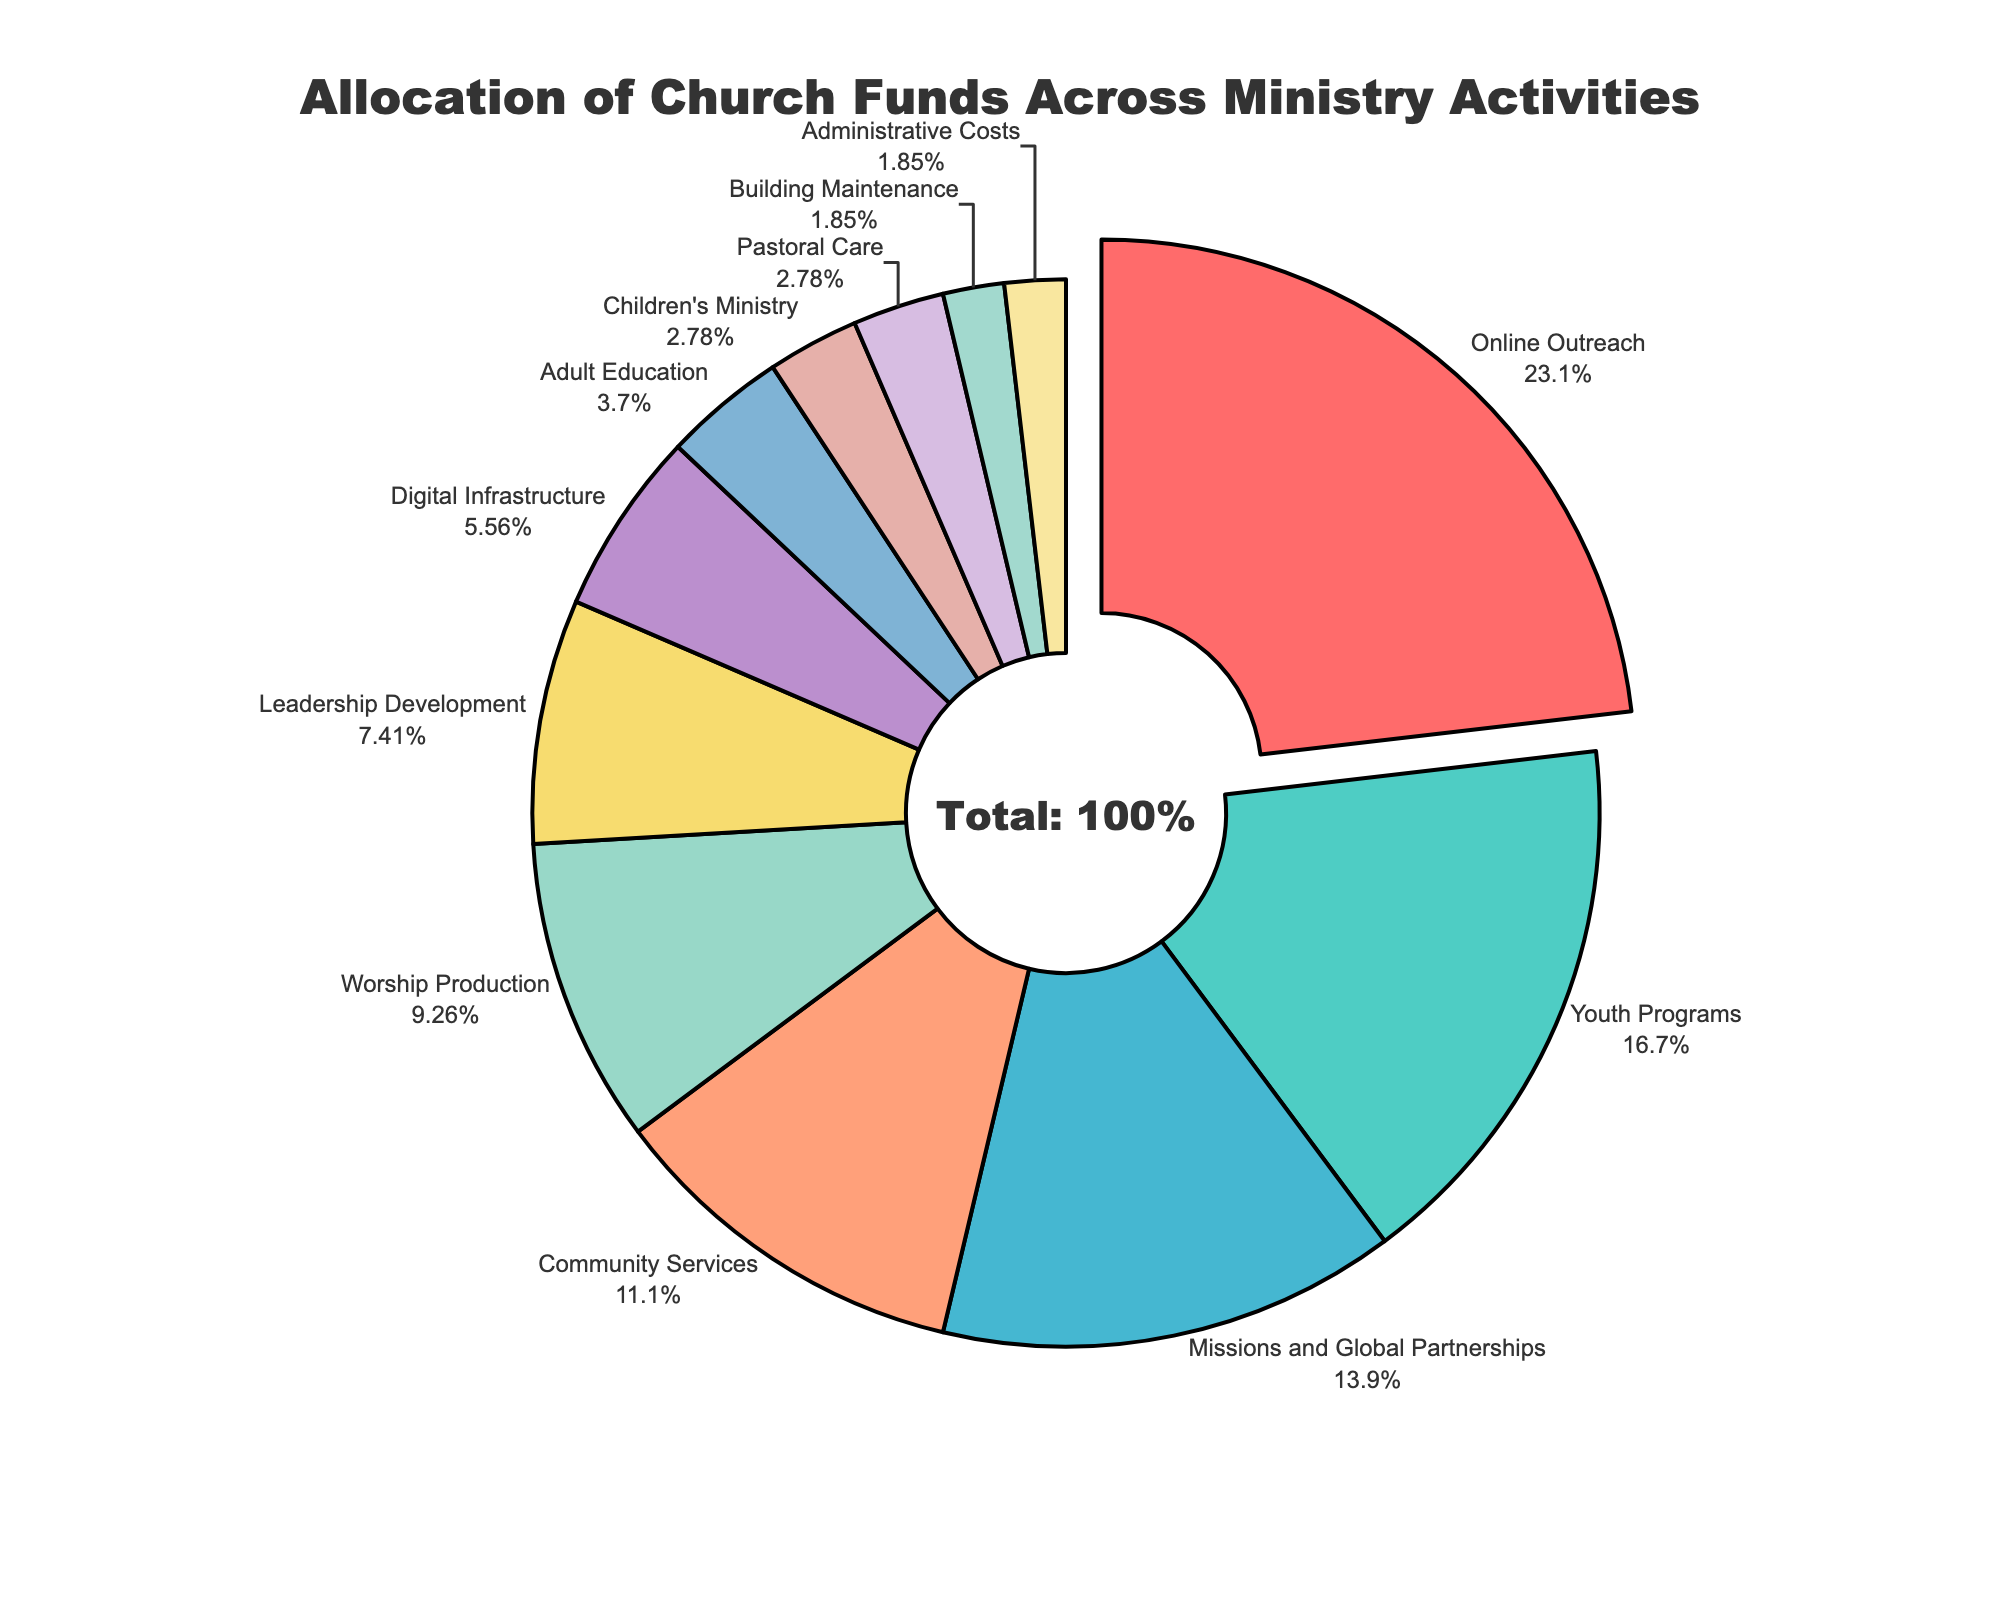What is the largest single allocation in the church fund distribution? Locate the slice representing the largest percentage. The 'Online Outreach' segment is the largest with 25%.
Answer: Online Outreach Which activities receive less than 5% of the church funds? Identify the activities with a percentage less than 5%. These are: 'Adult Education' (4%), 'Children's Ministry' (3%), 'Pastoral Care' (3%), 'Building Maintenance' (2%), and 'Administrative Costs' (2%).
Answer: Adult Education, Children's Ministry, Pastoral Care, Building Maintenance, Administrative Costs What is the total percentage allocated to digital-related activities (Online Outreach and Digital Infrastructure)? Sum the percentages for 'Online Outreach' (25%) and 'Digital Infrastructure' (6%). 25% + 6% = 31%.
Answer: 31% Which receives more funds: Youth Programs or Worship Production? Compare the percentages of 'Youth Programs' (18%) and 'Worship Production' (10%). 'Youth Programs' receives more.
Answer: Youth Programs If Community Services and Leadership Development were combined, what would be their total allocation? Add the percentages of 'Community Services' (12%) and 'Leadership Development' (8%). 12% + 8% = 20%.
Answer: 20% Which color segment corresponds to Children’s Ministry? Identify the color associated with the 'Children's Ministry' segment, which is the pale blue slice.
Answer: Pale Blue What is the combined percentage allocation of Pastoral Care and Children's Ministry? Add the percentages for 'Pastoral Care' (3%) and 'Children's Ministry' (3%). 3% + 3% = 6%.
Answer: 6% How does the allocation for Missions and Global Partnerships compare to Community Services? Compare the percentages of 'Missions and Global Partnerships' (15%) and 'Community Services' (12%). 'Missions and Global Partnerships' has a higher allocation.
Answer: Missions and Global Partnerships 